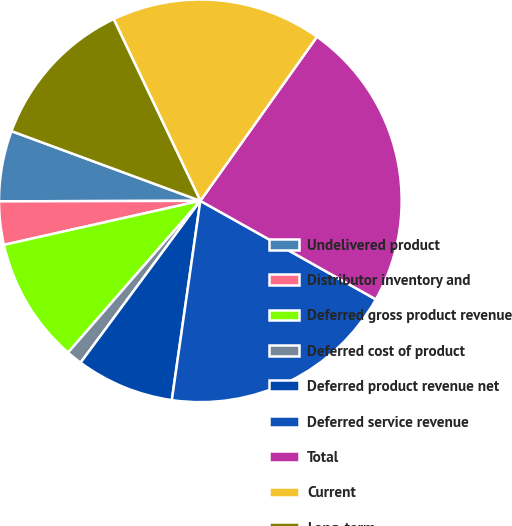Convert chart. <chart><loc_0><loc_0><loc_500><loc_500><pie_chart><fcel>Undelivered product<fcel>Distributor inventory and<fcel>Deferred gross product revenue<fcel>Deferred cost of product<fcel>Deferred product revenue net<fcel>Deferred service revenue<fcel>Total<fcel>Current<fcel>Long-term<nl><fcel>5.67%<fcel>3.47%<fcel>10.08%<fcel>1.27%<fcel>7.88%<fcel>19.12%<fcel>23.31%<fcel>16.92%<fcel>12.29%<nl></chart> 